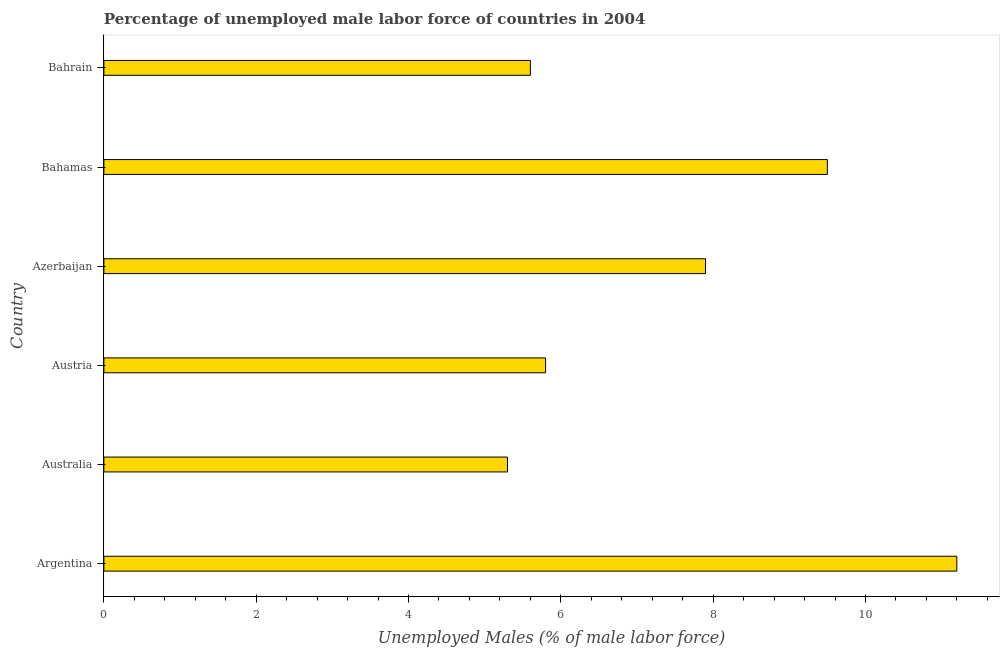Does the graph contain any zero values?
Your answer should be compact. No. Does the graph contain grids?
Ensure brevity in your answer.  No. What is the title of the graph?
Provide a succinct answer. Percentage of unemployed male labor force of countries in 2004. What is the label or title of the X-axis?
Make the answer very short. Unemployed Males (% of male labor force). What is the total unemployed male labour force in Australia?
Ensure brevity in your answer.  5.3. Across all countries, what is the maximum total unemployed male labour force?
Make the answer very short. 11.2. Across all countries, what is the minimum total unemployed male labour force?
Keep it short and to the point. 5.3. In which country was the total unemployed male labour force minimum?
Keep it short and to the point. Australia. What is the sum of the total unemployed male labour force?
Offer a terse response. 45.3. What is the difference between the total unemployed male labour force in Austria and Bahrain?
Keep it short and to the point. 0.2. What is the average total unemployed male labour force per country?
Make the answer very short. 7.55. What is the median total unemployed male labour force?
Keep it short and to the point. 6.85. What is the ratio of the total unemployed male labour force in Austria to that in Bahamas?
Keep it short and to the point. 0.61. Is the difference between the total unemployed male labour force in Azerbaijan and Bahrain greater than the difference between any two countries?
Your answer should be compact. No. How many bars are there?
Offer a very short reply. 6. Are all the bars in the graph horizontal?
Make the answer very short. Yes. What is the Unemployed Males (% of male labor force) in Argentina?
Offer a terse response. 11.2. What is the Unemployed Males (% of male labor force) in Australia?
Give a very brief answer. 5.3. What is the Unemployed Males (% of male labor force) in Austria?
Your answer should be very brief. 5.8. What is the Unemployed Males (% of male labor force) of Azerbaijan?
Your response must be concise. 7.9. What is the Unemployed Males (% of male labor force) of Bahrain?
Make the answer very short. 5.6. What is the difference between the Unemployed Males (% of male labor force) in Argentina and Australia?
Your response must be concise. 5.9. What is the difference between the Unemployed Males (% of male labor force) in Argentina and Austria?
Offer a very short reply. 5.4. What is the difference between the Unemployed Males (% of male labor force) in Australia and Austria?
Offer a very short reply. -0.5. What is the difference between the Unemployed Males (% of male labor force) in Australia and Bahrain?
Offer a terse response. -0.3. What is the difference between the Unemployed Males (% of male labor force) in Austria and Azerbaijan?
Ensure brevity in your answer.  -2.1. What is the ratio of the Unemployed Males (% of male labor force) in Argentina to that in Australia?
Offer a terse response. 2.11. What is the ratio of the Unemployed Males (% of male labor force) in Argentina to that in Austria?
Your answer should be compact. 1.93. What is the ratio of the Unemployed Males (% of male labor force) in Argentina to that in Azerbaijan?
Provide a short and direct response. 1.42. What is the ratio of the Unemployed Males (% of male labor force) in Argentina to that in Bahamas?
Your response must be concise. 1.18. What is the ratio of the Unemployed Males (% of male labor force) in Argentina to that in Bahrain?
Make the answer very short. 2. What is the ratio of the Unemployed Males (% of male labor force) in Australia to that in Austria?
Keep it short and to the point. 0.91. What is the ratio of the Unemployed Males (% of male labor force) in Australia to that in Azerbaijan?
Make the answer very short. 0.67. What is the ratio of the Unemployed Males (% of male labor force) in Australia to that in Bahamas?
Your response must be concise. 0.56. What is the ratio of the Unemployed Males (% of male labor force) in Australia to that in Bahrain?
Keep it short and to the point. 0.95. What is the ratio of the Unemployed Males (% of male labor force) in Austria to that in Azerbaijan?
Ensure brevity in your answer.  0.73. What is the ratio of the Unemployed Males (% of male labor force) in Austria to that in Bahamas?
Give a very brief answer. 0.61. What is the ratio of the Unemployed Males (% of male labor force) in Austria to that in Bahrain?
Make the answer very short. 1.04. What is the ratio of the Unemployed Males (% of male labor force) in Azerbaijan to that in Bahamas?
Offer a very short reply. 0.83. What is the ratio of the Unemployed Males (% of male labor force) in Azerbaijan to that in Bahrain?
Your answer should be compact. 1.41. What is the ratio of the Unemployed Males (% of male labor force) in Bahamas to that in Bahrain?
Offer a terse response. 1.7. 